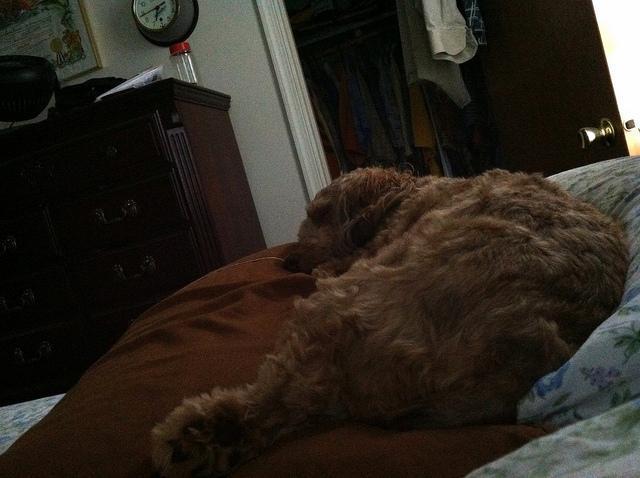What is on the bed?
Make your selection and explain in format: 'Answer: answer
Rationale: rationale.'
Options: Pet, woman, man, single rose. Answer: pet.
Rationale: The pet is on the bed. 